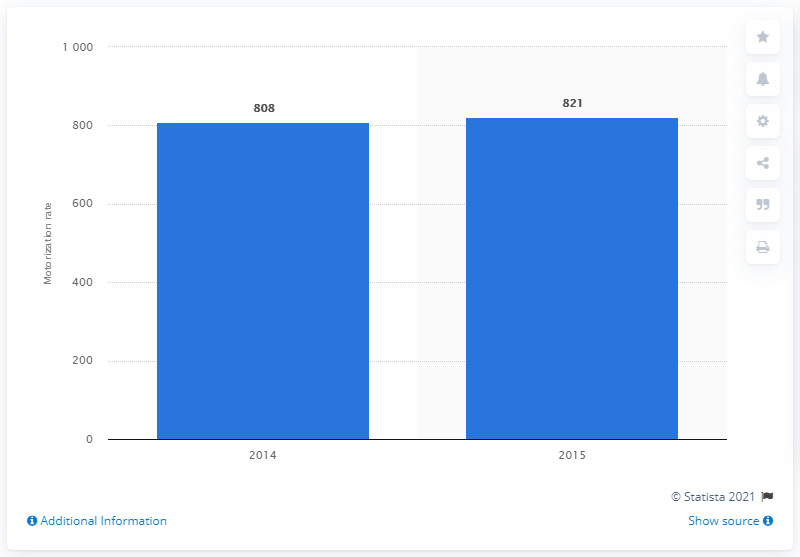Highlight a few significant elements in this photo. In 2015, a total of 821 million motor vehicles were used in the United States. 